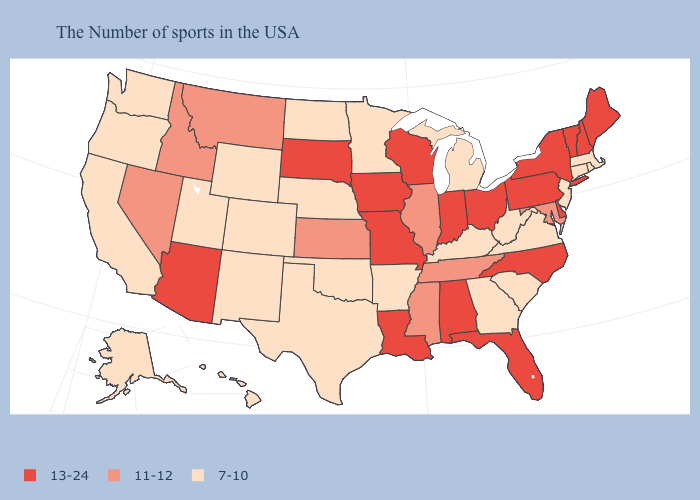Does Missouri have a higher value than New Hampshire?
Keep it brief. No. Which states hav the highest value in the MidWest?
Short answer required. Ohio, Indiana, Wisconsin, Missouri, Iowa, South Dakota. Does West Virginia have the same value as Massachusetts?
Give a very brief answer. Yes. What is the value of Rhode Island?
Be succinct. 7-10. Name the states that have a value in the range 7-10?
Answer briefly. Massachusetts, Rhode Island, Connecticut, New Jersey, Virginia, South Carolina, West Virginia, Georgia, Michigan, Kentucky, Arkansas, Minnesota, Nebraska, Oklahoma, Texas, North Dakota, Wyoming, Colorado, New Mexico, Utah, California, Washington, Oregon, Alaska, Hawaii. Name the states that have a value in the range 11-12?
Quick response, please. Maryland, Tennessee, Illinois, Mississippi, Kansas, Montana, Idaho, Nevada. Does the map have missing data?
Quick response, please. No. What is the lowest value in the South?
Short answer required. 7-10. What is the lowest value in the USA?
Give a very brief answer. 7-10. What is the value of Minnesota?
Give a very brief answer. 7-10. What is the highest value in the USA?
Be succinct. 13-24. What is the value of West Virginia?
Quick response, please. 7-10. Name the states that have a value in the range 11-12?
Keep it brief. Maryland, Tennessee, Illinois, Mississippi, Kansas, Montana, Idaho, Nevada. What is the lowest value in states that border Illinois?
Quick response, please. 7-10. What is the lowest value in the Northeast?
Write a very short answer. 7-10. 